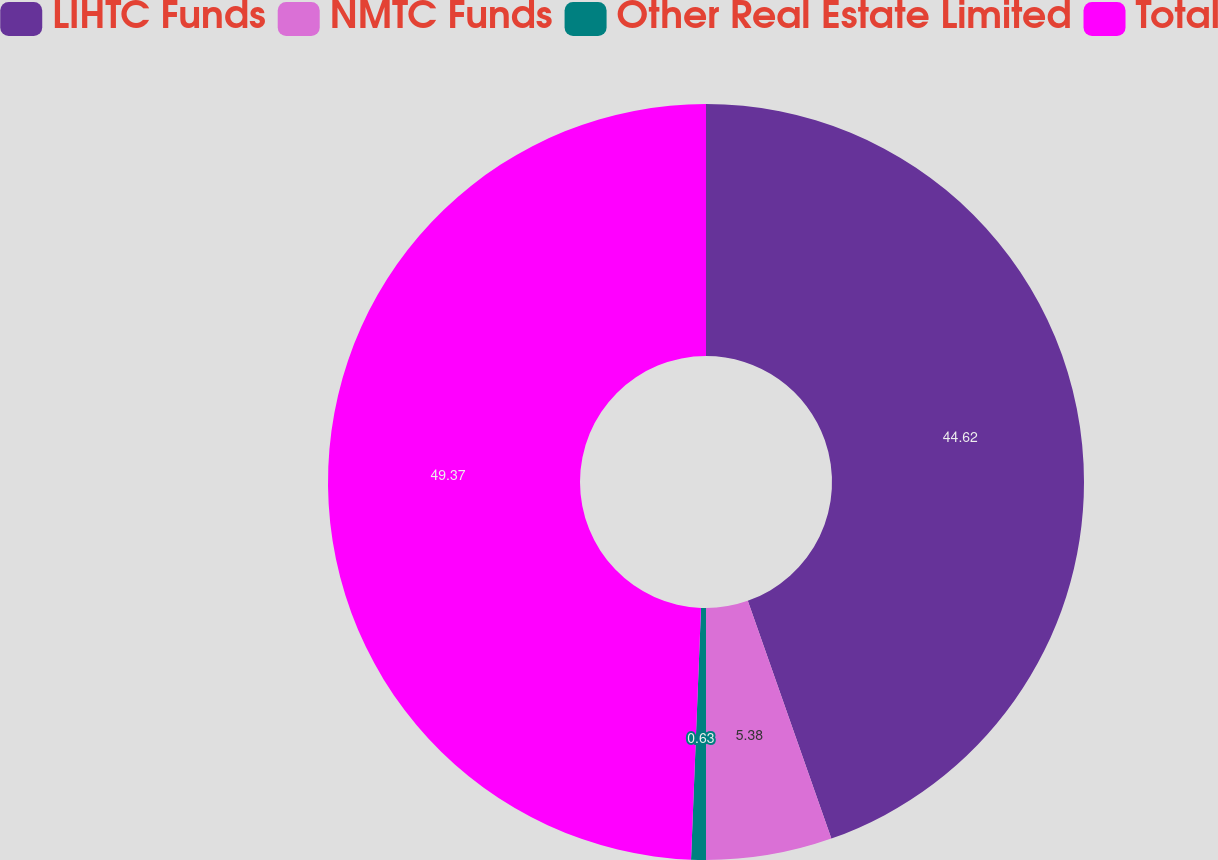<chart> <loc_0><loc_0><loc_500><loc_500><pie_chart><fcel>LIHTC Funds<fcel>NMTC Funds<fcel>Other Real Estate Limited<fcel>Total<nl><fcel>44.62%<fcel>5.38%<fcel>0.63%<fcel>49.37%<nl></chart> 